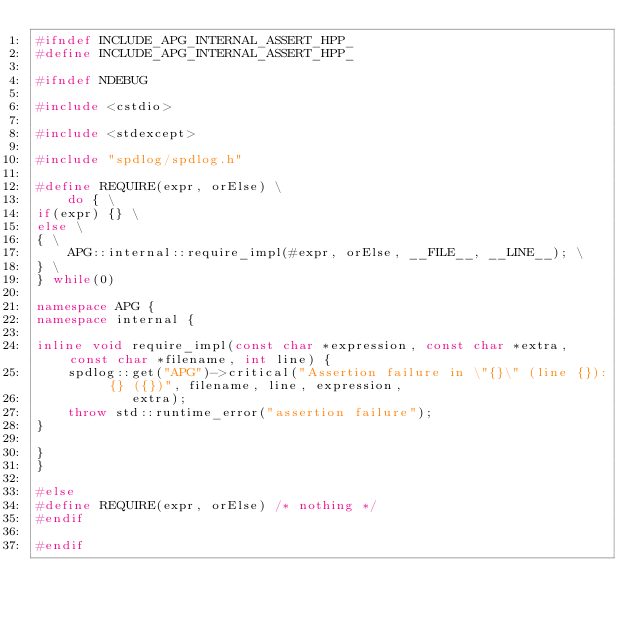<code> <loc_0><loc_0><loc_500><loc_500><_C++_>#ifndef INCLUDE_APG_INTERNAL_ASSERT_HPP_
#define INCLUDE_APG_INTERNAL_ASSERT_HPP_

#ifndef NDEBUG

#include <cstdio>

#include <stdexcept>

#include "spdlog/spdlog.h"

#define REQUIRE(expr, orElse) \
	do { \
if(expr) {} \
else \
{ \
	APG::internal::require_impl(#expr, orElse, __FILE__, __LINE__); \
} \
} while(0)

namespace APG {
namespace internal {

inline void require_impl(const char *expression, const char *extra, const char *filename, int line) {
	spdlog::get("APG")->critical("Assertion failure in \"{}\" (line {}): {} ({})", filename, line, expression,
	        extra);
	throw std::runtime_error("assertion failure");
}

}
}

#else
#define REQUIRE(expr, orElse) /* nothing */
#endif

#endif</code> 